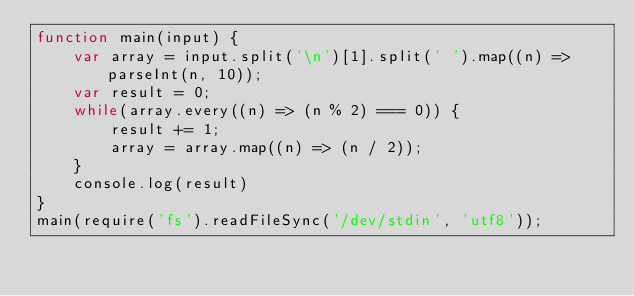<code> <loc_0><loc_0><loc_500><loc_500><_JavaScript_>function main(input) {
	var array = input.split('\n')[1].split(' ').map((n) => parseInt(n, 10));
	var result = 0;
	while(array.every((n) => (n % 2) === 0)) {
		result += 1;
		array = array.map((n) => (n / 2));
	}
	console.log(result)
}
main(require('fs').readFileSync('/dev/stdin', 'utf8'));</code> 